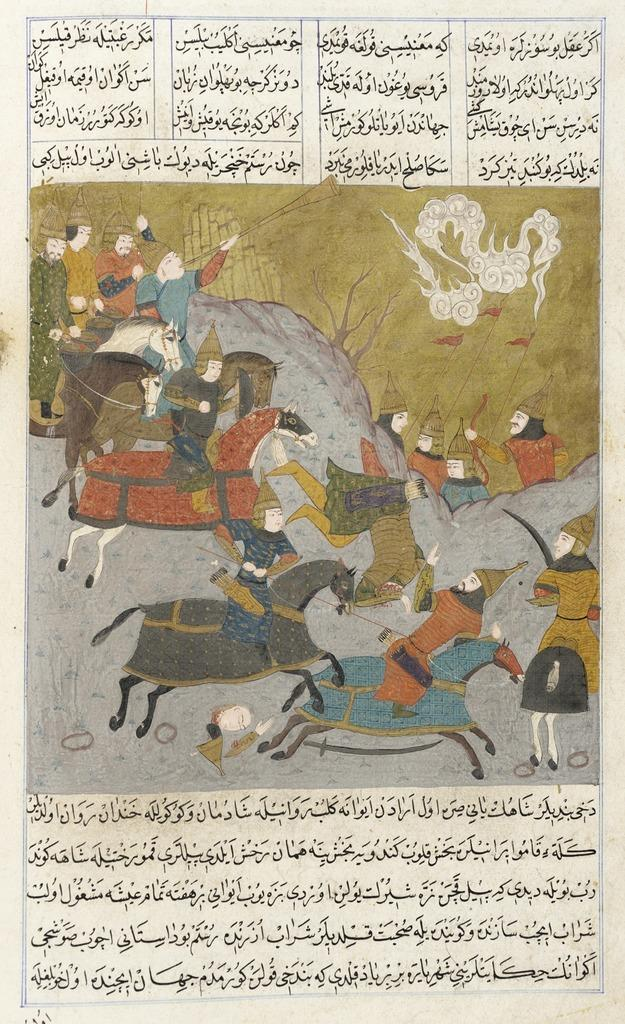What is the main object in the image? There is a paper in the image. What is depicted on the paper? The paper contains a picture of horses and persons. Is there any text on the paper? Yes, there is text on the paper. Where is the pocket located in the image? There is no pocket present in the image. What type of wash is recommended for the paper in the image? The paper in the image is not a physical object that requires washing. 